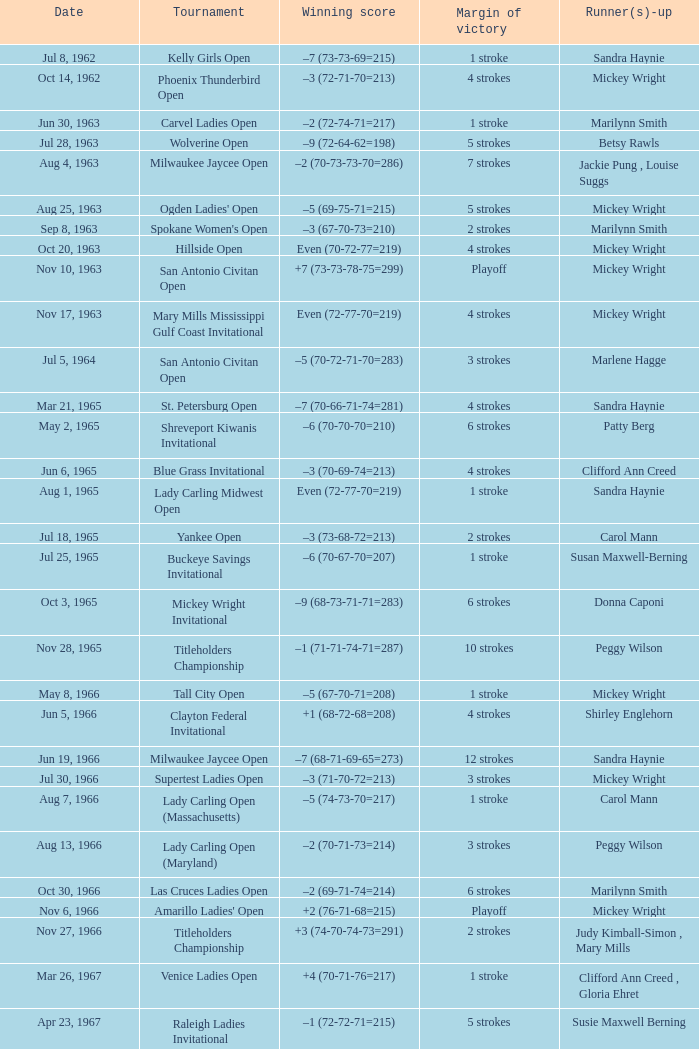When the advantage was 9 strokes, what was the triumphant score? –7 (73-68-73-67=281). 